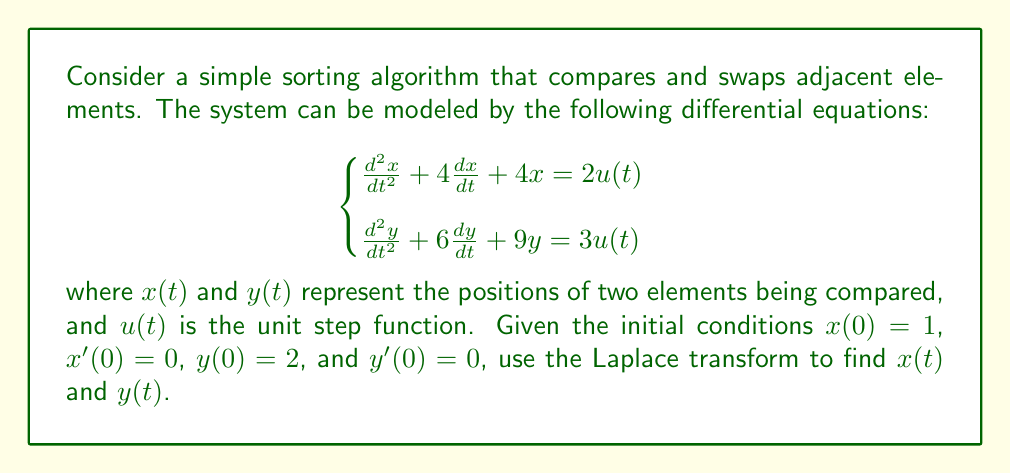Can you solve this math problem? Let's approach this step-by-step using the Laplace transform:

1) First, let's take the Laplace transform of both equations:

   $$\begin{cases}
   s^2X(s) - sx(0) - x'(0) + 4sX(s) - 4x(0) + 4X(s) = \frac{2}{s} \\
   s^2Y(s) - sy(0) - y'(0) + 6sY(s) - 6y(0) + 9Y(s) = \frac{3}{s}
   \end{cases}$$

2) Substitute the initial conditions:

   $$\begin{cases}
   s^2X(s) - s - 0 + 4sX(s) - 4 + 4X(s) = \frac{2}{s} \\
   s^2Y(s) - 2s - 0 + 6sY(s) - 12 + 9Y(s) = \frac{3}{s}
   \end{cases}$$

3) Simplify:

   $$\begin{cases}
   (s^2 + 4s + 4)X(s) = \frac{2}{s} + s + 4 \\
   (s^2 + 6s + 9)Y(s) = \frac{3}{s} + 2s + 12
   \end{cases}$$

4) Solve for $X(s)$ and $Y(s)$:

   $$\begin{cases}
   X(s) = \frac{2/s + s + 4}{(s+2)^2} = \frac{s^2 + 4s + 2}{s(s+2)^2} \\
   Y(s) = \frac{3/s + 2s + 12}{(s+3)^2} = \frac{2s^2 + 12s + 3}{s(s+3)^2}
   \end{cases}$$

5) Use partial fraction decomposition:

   $$\begin{cases}
   X(s) = \frac{1}{2} + \frac{1}{s} - \frac{1}{s+2} - \frac{1}{(s+2)^2} \\
   Y(s) = \frac{2}{3} + \frac{1}{s} - \frac{1}{s+3} - \frac{1}{(s+3)^2}
   \end{cases}$$

6) Take the inverse Laplace transform:

   $$\begin{cases}
   x(t) = \frac{1}{2} + 1 - e^{-2t} - te^{-2t} \\
   y(t) = \frac{2}{3} + 1 - e^{-3t} - te^{-3t}
   \end{cases}$$

7) Simplify:

   $$\begin{cases}
   x(t) = \frac{3}{2} - e^{-2t}(1 + t) \\
   y(t) = \frac{5}{3} - e^{-3t}(1 + t)
   \end{cases}$$

These functions represent the positions of the two elements over time as they are being sorted.
Answer: $$\begin{cases}
x(t) = \frac{3}{2} - e^{-2t}(1 + t) \\
y(t) = \frac{5}{3} - e^{-3t}(1 + t)
\end{cases}$$ 